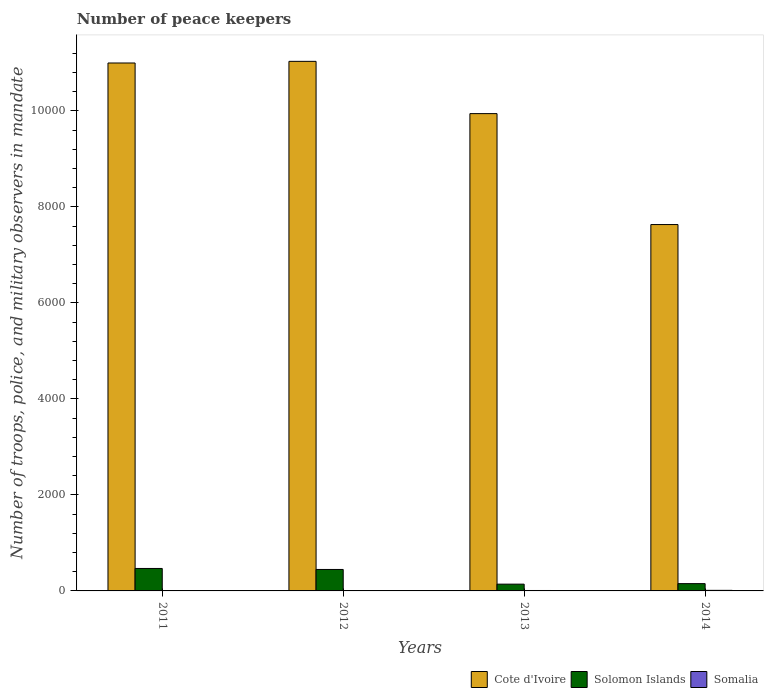How many bars are there on the 1st tick from the left?
Provide a short and direct response. 3. How many bars are there on the 1st tick from the right?
Your answer should be compact. 3. What is the label of the 3rd group of bars from the left?
Offer a very short reply. 2013. What is the number of peace keepers in in Cote d'Ivoire in 2014?
Keep it short and to the point. 7633. Across all years, what is the maximum number of peace keepers in in Cote d'Ivoire?
Ensure brevity in your answer.  1.10e+04. Across all years, what is the minimum number of peace keepers in in Cote d'Ivoire?
Your answer should be very brief. 7633. What is the total number of peace keepers in in Somalia in the graph?
Provide a succinct answer. 30. What is the difference between the number of peace keepers in in Solomon Islands in 2011 and that in 2014?
Offer a very short reply. 316. What is the difference between the number of peace keepers in in Cote d'Ivoire in 2014 and the number of peace keepers in in Somalia in 2013?
Provide a succinct answer. 7624. What is the average number of peace keepers in in Cote d'Ivoire per year?
Ensure brevity in your answer.  9902.25. In the year 2014, what is the difference between the number of peace keepers in in Cote d'Ivoire and number of peace keepers in in Somalia?
Provide a short and direct response. 7621. In how many years, is the number of peace keepers in in Cote d'Ivoire greater than 9600?
Offer a terse response. 3. What is the ratio of the number of peace keepers in in Solomon Islands in 2012 to that in 2013?
Your response must be concise. 3.17. Is the number of peace keepers in in Somalia in 2011 less than that in 2014?
Make the answer very short. Yes. In how many years, is the number of peace keepers in in Solomon Islands greater than the average number of peace keepers in in Solomon Islands taken over all years?
Ensure brevity in your answer.  2. Is the sum of the number of peace keepers in in Solomon Islands in 2011 and 2014 greater than the maximum number of peace keepers in in Cote d'Ivoire across all years?
Provide a short and direct response. No. What does the 1st bar from the left in 2011 represents?
Give a very brief answer. Cote d'Ivoire. What does the 1st bar from the right in 2012 represents?
Your response must be concise. Somalia. Is it the case that in every year, the sum of the number of peace keepers in in Solomon Islands and number of peace keepers in in Cote d'Ivoire is greater than the number of peace keepers in in Somalia?
Your response must be concise. Yes. Are all the bars in the graph horizontal?
Your response must be concise. No. What is the difference between two consecutive major ticks on the Y-axis?
Provide a succinct answer. 2000. Are the values on the major ticks of Y-axis written in scientific E-notation?
Keep it short and to the point. No. Does the graph contain grids?
Your answer should be compact. No. How many legend labels are there?
Make the answer very short. 3. What is the title of the graph?
Keep it short and to the point. Number of peace keepers. Does "Afghanistan" appear as one of the legend labels in the graph?
Provide a succinct answer. No. What is the label or title of the X-axis?
Ensure brevity in your answer.  Years. What is the label or title of the Y-axis?
Give a very brief answer. Number of troops, police, and military observers in mandate. What is the Number of troops, police, and military observers in mandate of Cote d'Ivoire in 2011?
Offer a very short reply. 1.10e+04. What is the Number of troops, police, and military observers in mandate of Solomon Islands in 2011?
Give a very brief answer. 468. What is the Number of troops, police, and military observers in mandate in Cote d'Ivoire in 2012?
Keep it short and to the point. 1.10e+04. What is the Number of troops, police, and military observers in mandate of Solomon Islands in 2012?
Keep it short and to the point. 447. What is the Number of troops, police, and military observers in mandate in Somalia in 2012?
Keep it short and to the point. 3. What is the Number of troops, police, and military observers in mandate in Cote d'Ivoire in 2013?
Your answer should be compact. 9944. What is the Number of troops, police, and military observers in mandate in Solomon Islands in 2013?
Keep it short and to the point. 141. What is the Number of troops, police, and military observers in mandate in Cote d'Ivoire in 2014?
Offer a terse response. 7633. What is the Number of troops, police, and military observers in mandate of Solomon Islands in 2014?
Offer a terse response. 152. What is the Number of troops, police, and military observers in mandate of Somalia in 2014?
Ensure brevity in your answer.  12. Across all years, what is the maximum Number of troops, police, and military observers in mandate in Cote d'Ivoire?
Offer a very short reply. 1.10e+04. Across all years, what is the maximum Number of troops, police, and military observers in mandate of Solomon Islands?
Offer a very short reply. 468. Across all years, what is the minimum Number of troops, police, and military observers in mandate of Cote d'Ivoire?
Ensure brevity in your answer.  7633. Across all years, what is the minimum Number of troops, police, and military observers in mandate in Solomon Islands?
Make the answer very short. 141. Across all years, what is the minimum Number of troops, police, and military observers in mandate in Somalia?
Provide a short and direct response. 3. What is the total Number of troops, police, and military observers in mandate of Cote d'Ivoire in the graph?
Ensure brevity in your answer.  3.96e+04. What is the total Number of troops, police, and military observers in mandate of Solomon Islands in the graph?
Your response must be concise. 1208. What is the difference between the Number of troops, police, and military observers in mandate in Cote d'Ivoire in 2011 and that in 2012?
Provide a succinct answer. -34. What is the difference between the Number of troops, police, and military observers in mandate in Cote d'Ivoire in 2011 and that in 2013?
Make the answer very short. 1055. What is the difference between the Number of troops, police, and military observers in mandate of Solomon Islands in 2011 and that in 2013?
Your answer should be compact. 327. What is the difference between the Number of troops, police, and military observers in mandate in Somalia in 2011 and that in 2013?
Offer a very short reply. -3. What is the difference between the Number of troops, police, and military observers in mandate of Cote d'Ivoire in 2011 and that in 2014?
Keep it short and to the point. 3366. What is the difference between the Number of troops, police, and military observers in mandate in Solomon Islands in 2011 and that in 2014?
Ensure brevity in your answer.  316. What is the difference between the Number of troops, police, and military observers in mandate of Cote d'Ivoire in 2012 and that in 2013?
Provide a succinct answer. 1089. What is the difference between the Number of troops, police, and military observers in mandate in Solomon Islands in 2012 and that in 2013?
Your response must be concise. 306. What is the difference between the Number of troops, police, and military observers in mandate in Somalia in 2012 and that in 2013?
Your answer should be compact. -6. What is the difference between the Number of troops, police, and military observers in mandate in Cote d'Ivoire in 2012 and that in 2014?
Offer a terse response. 3400. What is the difference between the Number of troops, police, and military observers in mandate in Solomon Islands in 2012 and that in 2014?
Give a very brief answer. 295. What is the difference between the Number of troops, police, and military observers in mandate in Somalia in 2012 and that in 2014?
Offer a very short reply. -9. What is the difference between the Number of troops, police, and military observers in mandate in Cote d'Ivoire in 2013 and that in 2014?
Ensure brevity in your answer.  2311. What is the difference between the Number of troops, police, and military observers in mandate of Solomon Islands in 2013 and that in 2014?
Ensure brevity in your answer.  -11. What is the difference between the Number of troops, police, and military observers in mandate of Somalia in 2013 and that in 2014?
Keep it short and to the point. -3. What is the difference between the Number of troops, police, and military observers in mandate of Cote d'Ivoire in 2011 and the Number of troops, police, and military observers in mandate of Solomon Islands in 2012?
Offer a very short reply. 1.06e+04. What is the difference between the Number of troops, police, and military observers in mandate in Cote d'Ivoire in 2011 and the Number of troops, police, and military observers in mandate in Somalia in 2012?
Your response must be concise. 1.10e+04. What is the difference between the Number of troops, police, and military observers in mandate in Solomon Islands in 2011 and the Number of troops, police, and military observers in mandate in Somalia in 2012?
Give a very brief answer. 465. What is the difference between the Number of troops, police, and military observers in mandate of Cote d'Ivoire in 2011 and the Number of troops, police, and military observers in mandate of Solomon Islands in 2013?
Offer a very short reply. 1.09e+04. What is the difference between the Number of troops, police, and military observers in mandate of Cote d'Ivoire in 2011 and the Number of troops, police, and military observers in mandate of Somalia in 2013?
Offer a very short reply. 1.10e+04. What is the difference between the Number of troops, police, and military observers in mandate of Solomon Islands in 2011 and the Number of troops, police, and military observers in mandate of Somalia in 2013?
Your response must be concise. 459. What is the difference between the Number of troops, police, and military observers in mandate in Cote d'Ivoire in 2011 and the Number of troops, police, and military observers in mandate in Solomon Islands in 2014?
Provide a short and direct response. 1.08e+04. What is the difference between the Number of troops, police, and military observers in mandate in Cote d'Ivoire in 2011 and the Number of troops, police, and military observers in mandate in Somalia in 2014?
Keep it short and to the point. 1.10e+04. What is the difference between the Number of troops, police, and military observers in mandate in Solomon Islands in 2011 and the Number of troops, police, and military observers in mandate in Somalia in 2014?
Ensure brevity in your answer.  456. What is the difference between the Number of troops, police, and military observers in mandate of Cote d'Ivoire in 2012 and the Number of troops, police, and military observers in mandate of Solomon Islands in 2013?
Offer a very short reply. 1.09e+04. What is the difference between the Number of troops, police, and military observers in mandate of Cote d'Ivoire in 2012 and the Number of troops, police, and military observers in mandate of Somalia in 2013?
Your response must be concise. 1.10e+04. What is the difference between the Number of troops, police, and military observers in mandate in Solomon Islands in 2012 and the Number of troops, police, and military observers in mandate in Somalia in 2013?
Ensure brevity in your answer.  438. What is the difference between the Number of troops, police, and military observers in mandate in Cote d'Ivoire in 2012 and the Number of troops, police, and military observers in mandate in Solomon Islands in 2014?
Your answer should be very brief. 1.09e+04. What is the difference between the Number of troops, police, and military observers in mandate of Cote d'Ivoire in 2012 and the Number of troops, police, and military observers in mandate of Somalia in 2014?
Your answer should be very brief. 1.10e+04. What is the difference between the Number of troops, police, and military observers in mandate in Solomon Islands in 2012 and the Number of troops, police, and military observers in mandate in Somalia in 2014?
Your answer should be very brief. 435. What is the difference between the Number of troops, police, and military observers in mandate in Cote d'Ivoire in 2013 and the Number of troops, police, and military observers in mandate in Solomon Islands in 2014?
Provide a succinct answer. 9792. What is the difference between the Number of troops, police, and military observers in mandate of Cote d'Ivoire in 2013 and the Number of troops, police, and military observers in mandate of Somalia in 2014?
Give a very brief answer. 9932. What is the difference between the Number of troops, police, and military observers in mandate of Solomon Islands in 2013 and the Number of troops, police, and military observers in mandate of Somalia in 2014?
Provide a short and direct response. 129. What is the average Number of troops, police, and military observers in mandate in Cote d'Ivoire per year?
Provide a short and direct response. 9902.25. What is the average Number of troops, police, and military observers in mandate in Solomon Islands per year?
Offer a terse response. 302. In the year 2011, what is the difference between the Number of troops, police, and military observers in mandate of Cote d'Ivoire and Number of troops, police, and military observers in mandate of Solomon Islands?
Your answer should be compact. 1.05e+04. In the year 2011, what is the difference between the Number of troops, police, and military observers in mandate in Cote d'Ivoire and Number of troops, police, and military observers in mandate in Somalia?
Provide a succinct answer. 1.10e+04. In the year 2011, what is the difference between the Number of troops, police, and military observers in mandate of Solomon Islands and Number of troops, police, and military observers in mandate of Somalia?
Ensure brevity in your answer.  462. In the year 2012, what is the difference between the Number of troops, police, and military observers in mandate in Cote d'Ivoire and Number of troops, police, and military observers in mandate in Solomon Islands?
Provide a succinct answer. 1.06e+04. In the year 2012, what is the difference between the Number of troops, police, and military observers in mandate of Cote d'Ivoire and Number of troops, police, and military observers in mandate of Somalia?
Provide a short and direct response. 1.10e+04. In the year 2012, what is the difference between the Number of troops, police, and military observers in mandate of Solomon Islands and Number of troops, police, and military observers in mandate of Somalia?
Give a very brief answer. 444. In the year 2013, what is the difference between the Number of troops, police, and military observers in mandate in Cote d'Ivoire and Number of troops, police, and military observers in mandate in Solomon Islands?
Offer a terse response. 9803. In the year 2013, what is the difference between the Number of troops, police, and military observers in mandate of Cote d'Ivoire and Number of troops, police, and military observers in mandate of Somalia?
Provide a succinct answer. 9935. In the year 2013, what is the difference between the Number of troops, police, and military observers in mandate of Solomon Islands and Number of troops, police, and military observers in mandate of Somalia?
Your response must be concise. 132. In the year 2014, what is the difference between the Number of troops, police, and military observers in mandate in Cote d'Ivoire and Number of troops, police, and military observers in mandate in Solomon Islands?
Provide a succinct answer. 7481. In the year 2014, what is the difference between the Number of troops, police, and military observers in mandate of Cote d'Ivoire and Number of troops, police, and military observers in mandate of Somalia?
Your answer should be very brief. 7621. In the year 2014, what is the difference between the Number of troops, police, and military observers in mandate in Solomon Islands and Number of troops, police, and military observers in mandate in Somalia?
Your answer should be very brief. 140. What is the ratio of the Number of troops, police, and military observers in mandate in Solomon Islands in 2011 to that in 2012?
Provide a succinct answer. 1.05. What is the ratio of the Number of troops, police, and military observers in mandate of Somalia in 2011 to that in 2012?
Provide a short and direct response. 2. What is the ratio of the Number of troops, police, and military observers in mandate of Cote d'Ivoire in 2011 to that in 2013?
Your answer should be compact. 1.11. What is the ratio of the Number of troops, police, and military observers in mandate in Solomon Islands in 2011 to that in 2013?
Offer a very short reply. 3.32. What is the ratio of the Number of troops, police, and military observers in mandate in Somalia in 2011 to that in 2013?
Provide a short and direct response. 0.67. What is the ratio of the Number of troops, police, and military observers in mandate of Cote d'Ivoire in 2011 to that in 2014?
Give a very brief answer. 1.44. What is the ratio of the Number of troops, police, and military observers in mandate of Solomon Islands in 2011 to that in 2014?
Provide a succinct answer. 3.08. What is the ratio of the Number of troops, police, and military observers in mandate in Cote d'Ivoire in 2012 to that in 2013?
Your response must be concise. 1.11. What is the ratio of the Number of troops, police, and military observers in mandate of Solomon Islands in 2012 to that in 2013?
Your answer should be very brief. 3.17. What is the ratio of the Number of troops, police, and military observers in mandate of Somalia in 2012 to that in 2013?
Ensure brevity in your answer.  0.33. What is the ratio of the Number of troops, police, and military observers in mandate in Cote d'Ivoire in 2012 to that in 2014?
Provide a short and direct response. 1.45. What is the ratio of the Number of troops, police, and military observers in mandate in Solomon Islands in 2012 to that in 2014?
Your answer should be compact. 2.94. What is the ratio of the Number of troops, police, and military observers in mandate in Cote d'Ivoire in 2013 to that in 2014?
Offer a very short reply. 1.3. What is the ratio of the Number of troops, police, and military observers in mandate of Solomon Islands in 2013 to that in 2014?
Offer a very short reply. 0.93. What is the ratio of the Number of troops, police, and military observers in mandate of Somalia in 2013 to that in 2014?
Provide a succinct answer. 0.75. What is the difference between the highest and the second highest Number of troops, police, and military observers in mandate in Somalia?
Ensure brevity in your answer.  3. What is the difference between the highest and the lowest Number of troops, police, and military observers in mandate of Cote d'Ivoire?
Ensure brevity in your answer.  3400. What is the difference between the highest and the lowest Number of troops, police, and military observers in mandate in Solomon Islands?
Keep it short and to the point. 327. 